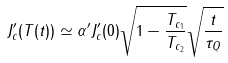<formula> <loc_0><loc_0><loc_500><loc_500>J _ { c } ^ { \prime } ( T ( t ) ) \simeq \alpha ^ { \prime } J _ { c } ^ { \prime } ( 0 ) \sqrt { 1 - \frac { T _ { c _ { 1 } } } { T _ { c _ { 2 } } } } \sqrt { \frac { t } { \tau _ { Q } } }</formula> 